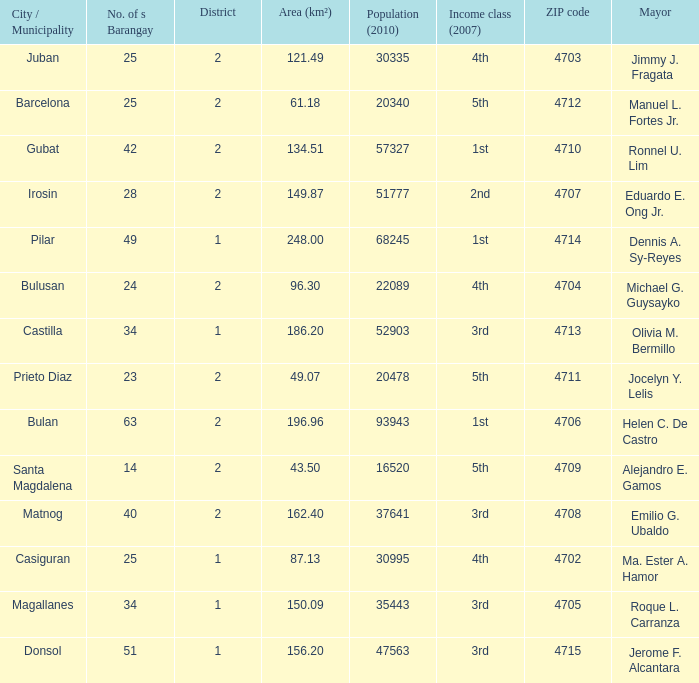Could you parse the entire table as a dict? {'header': ['City / Municipality', 'No. of s Barangay', 'District', 'Area (km²)', 'Population (2010)', 'Income class (2007)', 'ZIP code', 'Mayor'], 'rows': [['Juban', '25', '2', '121.49', '30335', '4th', '4703', 'Jimmy J. Fragata'], ['Barcelona', '25', '2', '61.18', '20340', '5th', '4712', 'Manuel L. Fortes Jr.'], ['Gubat', '42', '2', '134.51', '57327', '1st', '4710', 'Ronnel U. Lim'], ['Irosin', '28', '2', '149.87', '51777', '2nd', '4707', 'Eduardo E. Ong Jr.'], ['Pilar', '49', '1', '248.00', '68245', '1st', '4714', 'Dennis A. Sy-Reyes'], ['Bulusan', '24', '2', '96.30', '22089', '4th', '4704', 'Michael G. Guysayko'], ['Castilla', '34', '1', '186.20', '52903', '3rd', '4713', 'Olivia M. Bermillo'], ['Prieto Diaz', '23', '2', '49.07', '20478', '5th', '4711', 'Jocelyn Y. Lelis'], ['Bulan', '63', '2', '196.96', '93943', '1st', '4706', 'Helen C. De Castro'], ['Santa Magdalena', '14', '2', '43.50', '16520', '5th', '4709', 'Alejandro E. Gamos'], ['Matnog', '40', '2', '162.40', '37641', '3rd', '4708', 'Emilio G. Ubaldo'], ['Casiguran', '25', '1', '87.13', '30995', '4th', '4702', 'Ma. Ester A. Hamor'], ['Magallanes', '34', '1', '150.09', '35443', '3rd', '4705', 'Roque L. Carranza'], ['Donsol', '51', '1', '156.20', '47563', '3rd', '4715', 'Jerome F. Alcantara']]} What are all the vicinity (km²) where profits magnificence (2007) is 2nd 149.87. 